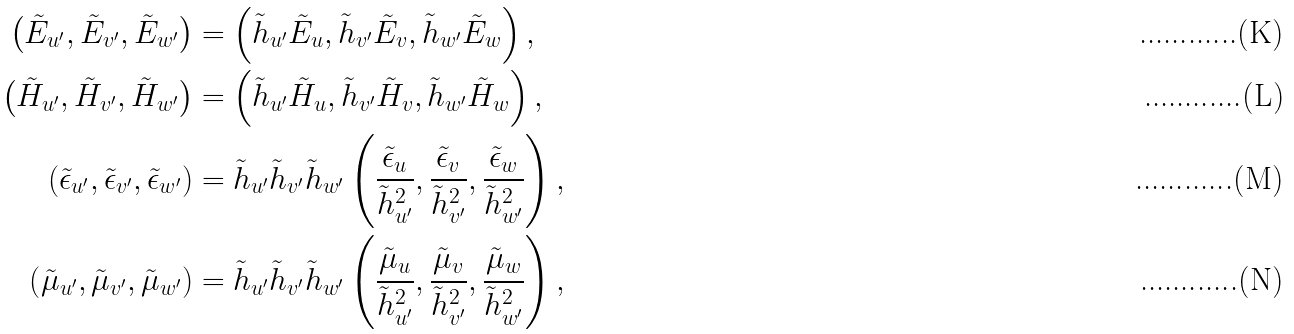Convert formula to latex. <formula><loc_0><loc_0><loc_500><loc_500>\left ( \tilde { E } _ { u ^ { \prime } } , \tilde { E } _ { v ^ { \prime } } , \tilde { E } _ { w ^ { \prime } } \right ) & = \left ( \tilde { h } _ { u ^ { \prime } } \tilde { E } _ { u } , \tilde { h } _ { v ^ { \prime } } \tilde { E } _ { v } , \tilde { h } _ { w ^ { \prime } } \tilde { E } _ { w } \right ) , \\ \left ( \tilde { H } _ { u ^ { \prime } } , \tilde { H } _ { v ^ { \prime } } , \tilde { H } _ { w ^ { \prime } } \right ) & = \left ( \tilde { h } _ { u ^ { \prime } } \tilde { H } _ { u } , \tilde { h } _ { v ^ { \prime } } \tilde { H } _ { v } , \tilde { h } _ { w ^ { \prime } } \tilde { H } _ { w } \right ) , \\ \left ( \tilde { \epsilon } _ { u ^ { \prime } } , \tilde { \epsilon } _ { v ^ { \prime } } , \tilde { \epsilon } _ { w ^ { \prime } } \right ) & = \tilde { h } _ { u ^ { \prime } } \tilde { h } _ { v ^ { \prime } } \tilde { h } _ { w ^ { \prime } } \left ( \frac { \tilde { \epsilon } _ { u } } { \tilde { h } _ { u ^ { \prime } } ^ { 2 } } , \frac { \tilde { \epsilon } _ { v } } { \tilde { h } _ { v ^ { \prime } } ^ { 2 } } , \frac { \tilde { \epsilon } _ { w } } { \tilde { h } _ { w ^ { \prime } } ^ { 2 } } \right ) , \\ \left ( \tilde { \mu } _ { u ^ { \prime } } , \tilde { \mu } _ { v ^ { \prime } } , \tilde { \mu } _ { w ^ { \prime } } \right ) & = \tilde { h } _ { u ^ { \prime } } \tilde { h } _ { v ^ { \prime } } \tilde { h } _ { w ^ { \prime } } \left ( \frac { \tilde { \mu } _ { u } } { \tilde { h } _ { u ^ { \prime } } ^ { 2 } } , \frac { \tilde { \mu } _ { v } } { \tilde { h } _ { v ^ { \prime } } ^ { 2 } } , \frac { \tilde { \mu } _ { w } } { \tilde { h } _ { w ^ { \prime } } ^ { 2 } } \right ) ,</formula> 